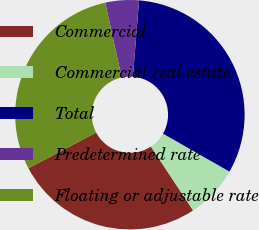<chart> <loc_0><loc_0><loc_500><loc_500><pie_chart><fcel>Commercial<fcel>Commercial real estate<fcel>Total<fcel>Predetermined rate<fcel>Floating or adjustable rate<nl><fcel>26.56%<fcel>7.45%<fcel>31.99%<fcel>4.73%<fcel>29.27%<nl></chart> 